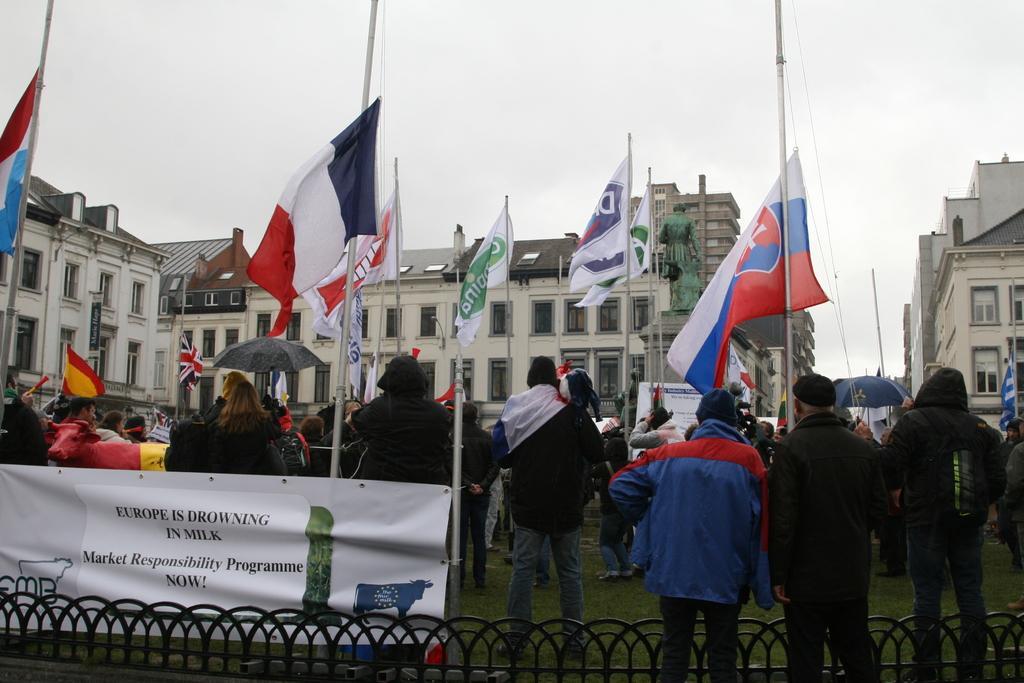Could you give a brief overview of what you see in this image? At the bottom, we see a railing. In front of the picture, we see three men are standing. Beside the railing, we see a banner in white color with some text written on it. In front of them, we see many flagpoles and flags which are in white, red, blue, yellow and green color. In the middle of the picture, we see many people are standing. The woman in black jacket is holding a black umbrella in her hands. There are buildings in the background and we even see the statue. At the top, we see the sky. 